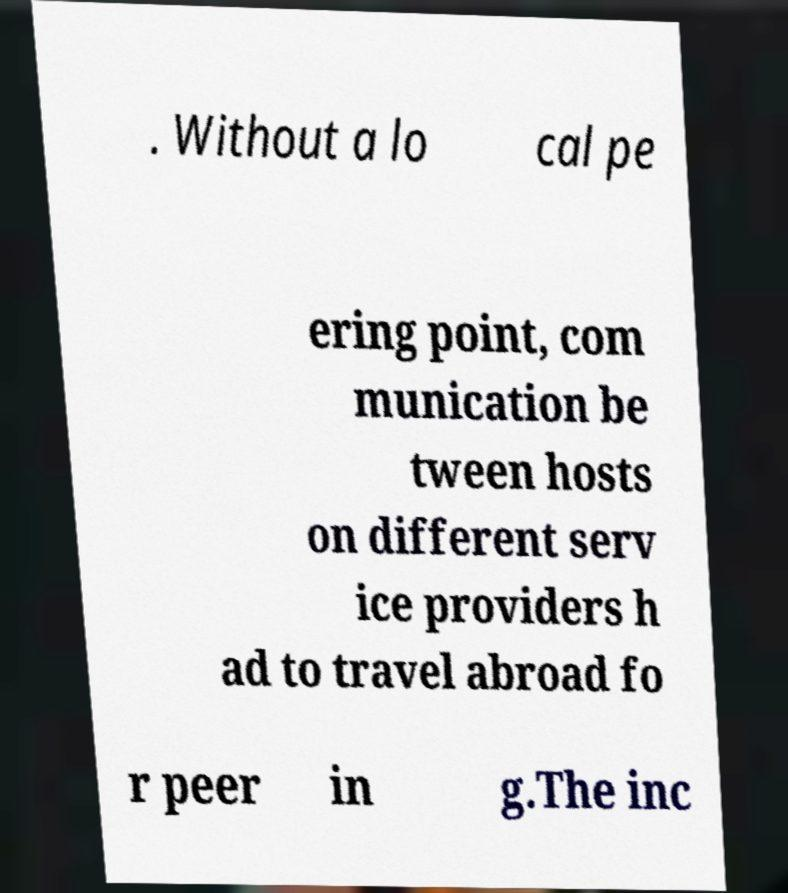Could you extract and type out the text from this image? . Without a lo cal pe ering point, com munication be tween hosts on different serv ice providers h ad to travel abroad fo r peer in g.The inc 